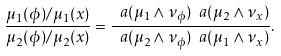<formula> <loc_0><loc_0><loc_500><loc_500>\frac { \mu _ { 1 } ( \phi ) / \mu _ { 1 } ( x ) } { \mu _ { 2 } ( \phi ) / \mu _ { 2 } ( x ) } = \frac { \ a ( \mu _ { 1 } \wedge \nu _ { \phi } ) \ a ( \mu _ { 2 } \wedge \nu _ { x } ) } { \ a ( \mu _ { 2 } \wedge \nu _ { \phi } ) \ a ( \mu _ { 1 } \wedge \nu _ { x } ) } .</formula> 